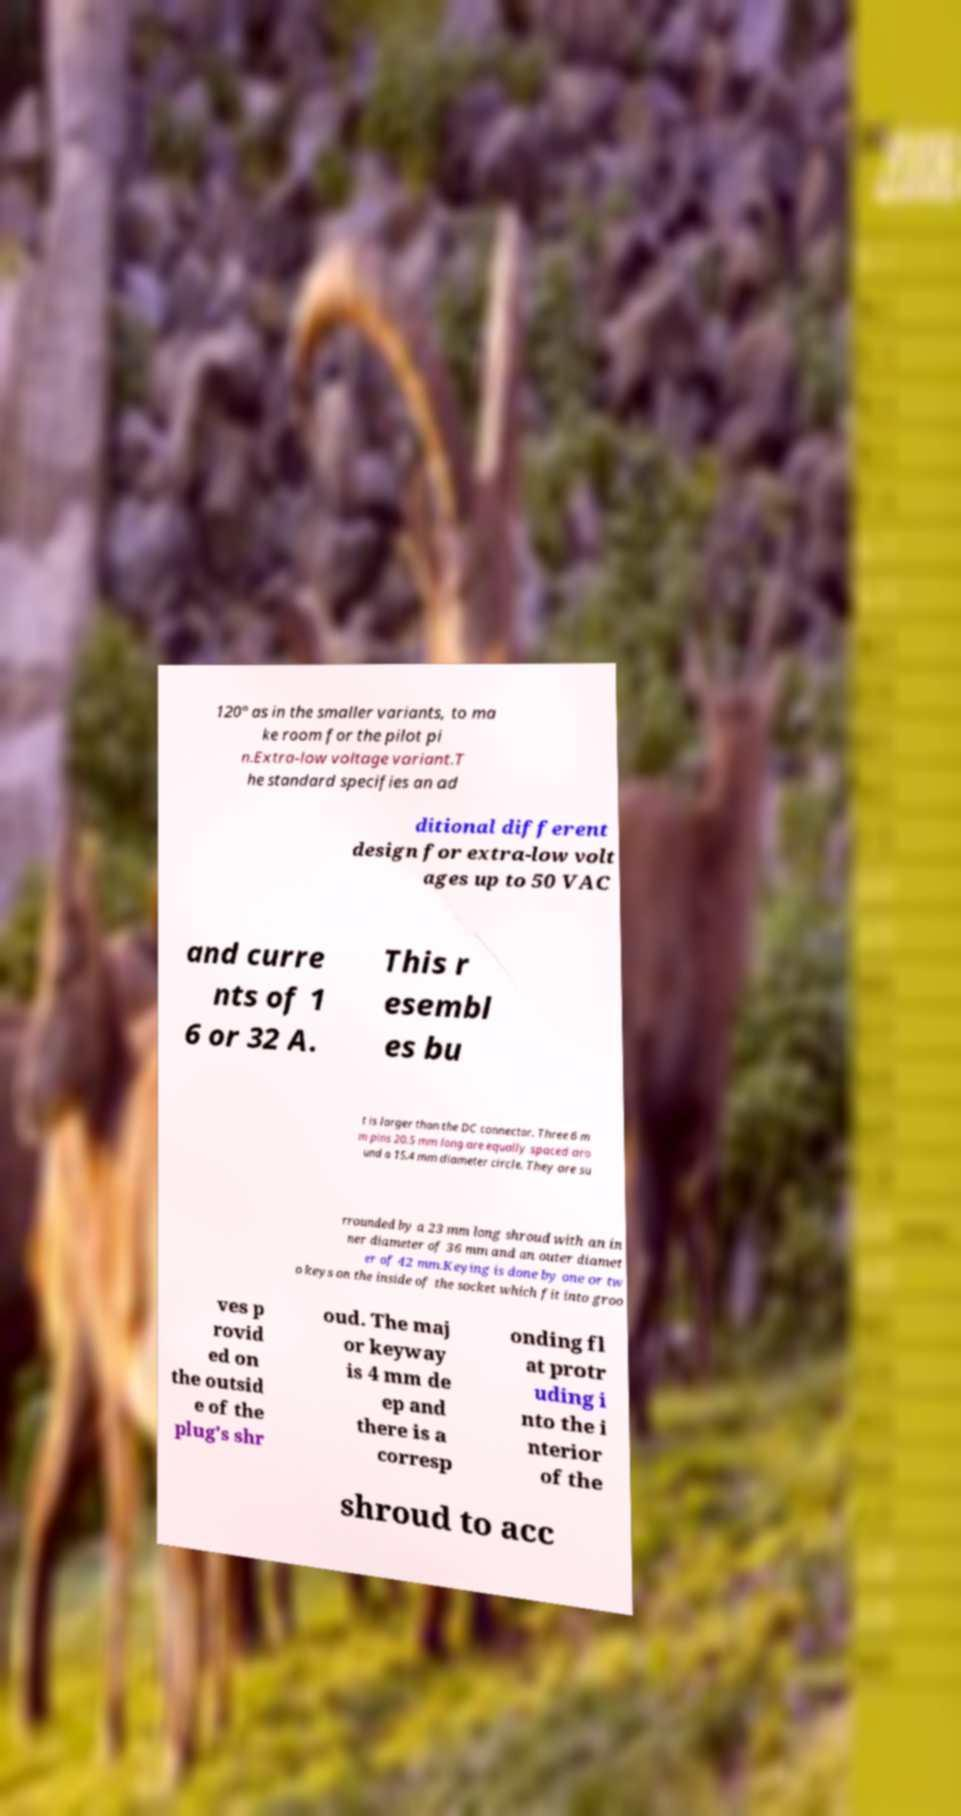There's text embedded in this image that I need extracted. Can you transcribe it verbatim? 120° as in the smaller variants, to ma ke room for the pilot pi n.Extra-low voltage variant.T he standard specifies an ad ditional different design for extra-low volt ages up to 50 VAC and curre nts of 1 6 or 32 A. This r esembl es bu t is larger than the DC connector. Three 6 m m pins 20.5 mm long are equally spaced aro und a 15.4 mm diameter circle. They are su rrounded by a 23 mm long shroud with an in ner diameter of 36 mm and an outer diamet er of 42 mm.Keying is done by one or tw o keys on the inside of the socket which fit into groo ves p rovid ed on the outsid e of the plug's shr oud. The maj or keyway is 4 mm de ep and there is a corresp onding fl at protr uding i nto the i nterior of the shroud to acc 